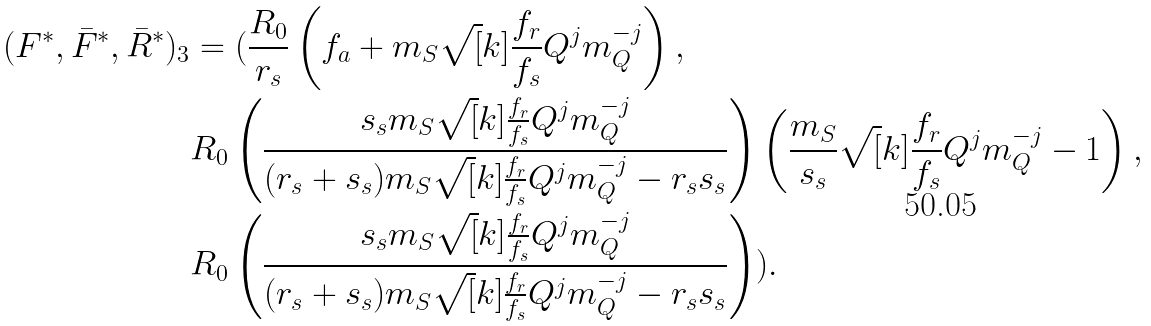Convert formula to latex. <formula><loc_0><loc_0><loc_500><loc_500>( F ^ { * } , \bar { F } ^ { * } , \bar { R } ^ { * } ) _ { 3 } & = ( \frac { R _ { 0 } } { r _ { s } } \left ( f _ { a } + m _ { S } \sqrt { [ } k ] { \frac { f _ { r } } { f _ { s } } Q ^ { j } m _ { Q } ^ { - j } } \right ) , \\ & R _ { 0 } \left ( \frac { s _ { s } m _ { S } \sqrt { [ } k ] { \frac { f _ { r } } { f _ { s } } Q ^ { j } m _ { Q } ^ { - j } } } { ( r _ { s } + s _ { s } ) m _ { S } \sqrt { [ } k ] { \frac { f _ { r } } { f _ { s } } Q ^ { j } m _ { Q } ^ { - j } } - r _ { s } s _ { s } } \right ) \left ( \frac { m _ { S } } { s _ { s } } \sqrt { [ } k ] { \frac { f _ { r } } { f _ { s } } Q ^ { j } m _ { Q } ^ { - j } } - 1 \right ) , \\ & R _ { 0 } \left ( \frac { s _ { s } m _ { S } \sqrt { [ } k ] { \frac { f _ { r } } { f _ { s } } Q ^ { j } m _ { Q } ^ { - j } } } { ( r _ { s } + s _ { s } ) m _ { S } \sqrt { [ } k ] { \frac { f _ { r } } { f _ { s } } Q ^ { j } m _ { Q } ^ { - j } } - r _ { s } s _ { s } } \right ) ) .</formula> 